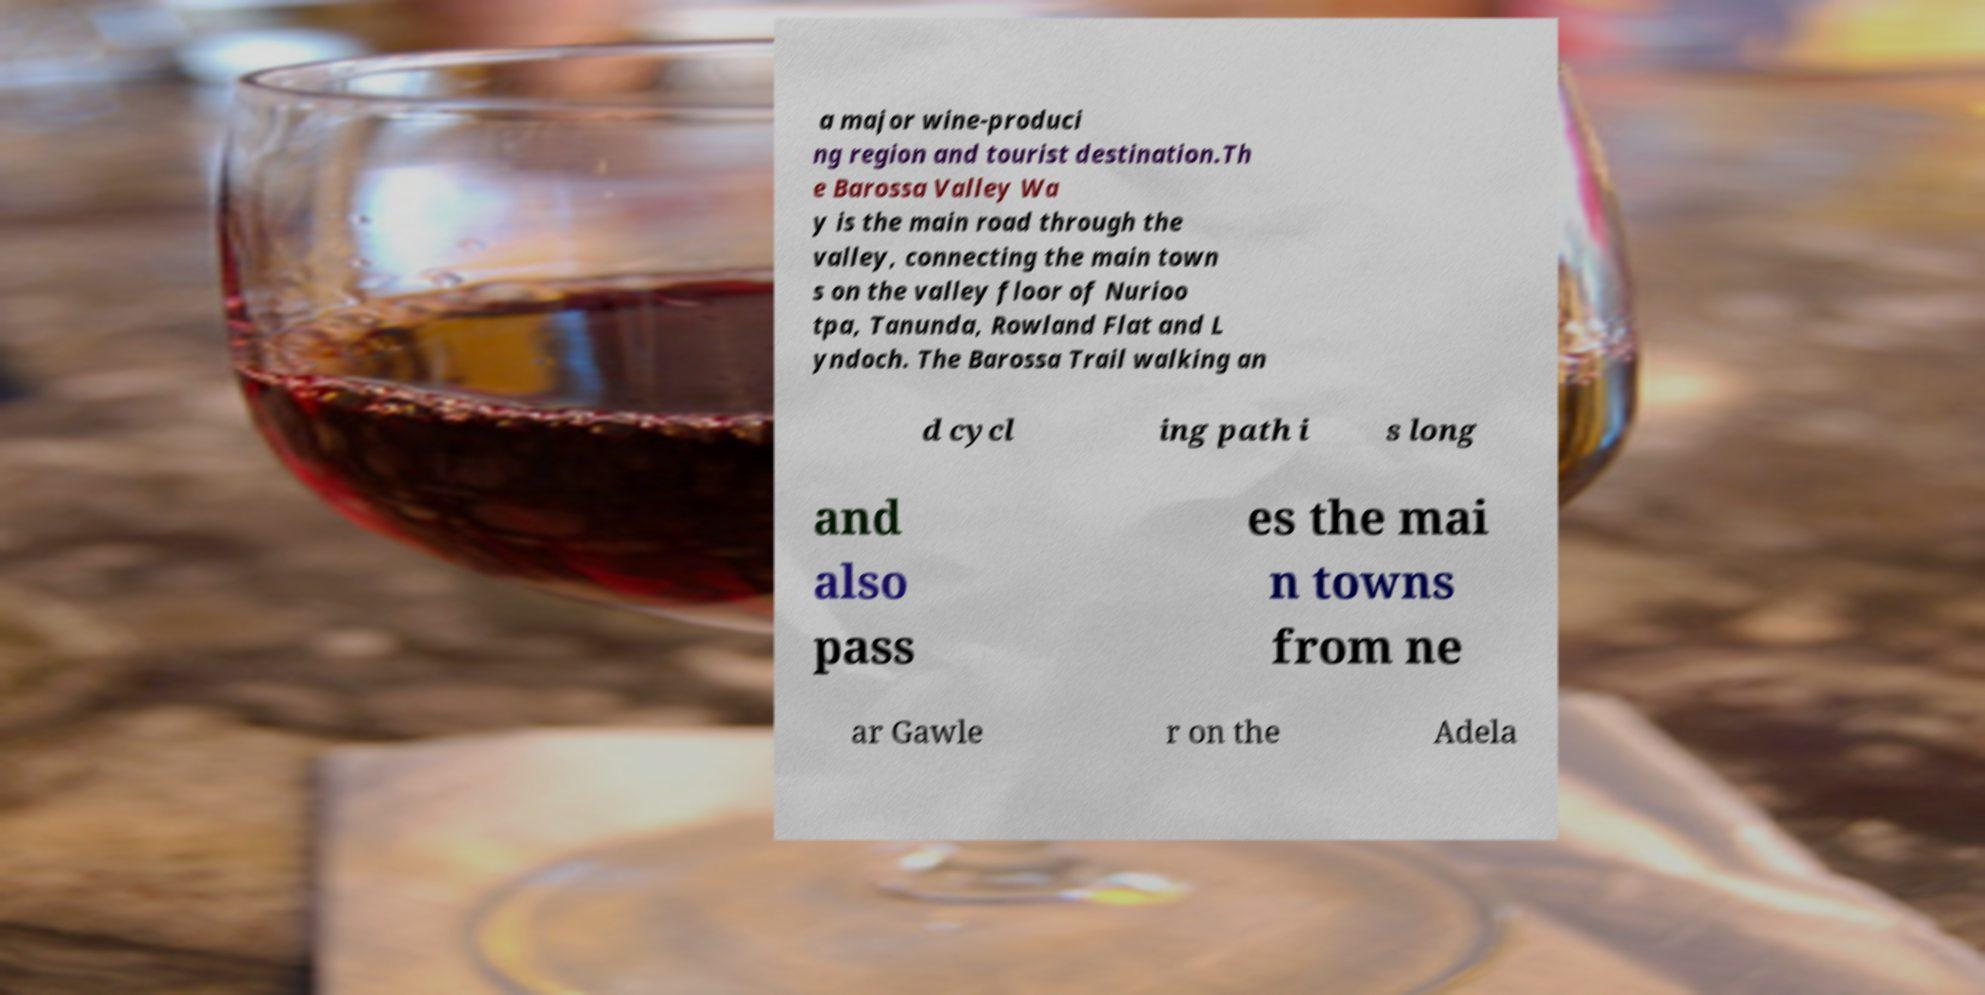I need the written content from this picture converted into text. Can you do that? a major wine-produci ng region and tourist destination.Th e Barossa Valley Wa y is the main road through the valley, connecting the main town s on the valley floor of Nurioo tpa, Tanunda, Rowland Flat and L yndoch. The Barossa Trail walking an d cycl ing path i s long and also pass es the mai n towns from ne ar Gawle r on the Adela 